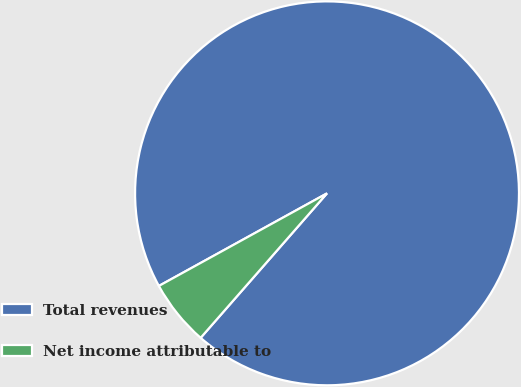Convert chart to OTSL. <chart><loc_0><loc_0><loc_500><loc_500><pie_chart><fcel>Total revenues<fcel>Net income attributable to<nl><fcel>94.45%<fcel>5.55%<nl></chart> 